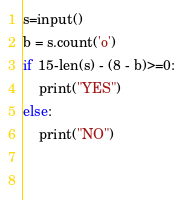<code> <loc_0><loc_0><loc_500><loc_500><_Python_>
s=input()
b = s.count('o')
if 15-len(s) - (8 - b)>=0:
    print("YES")
else:
    print("NO")

 </code> 